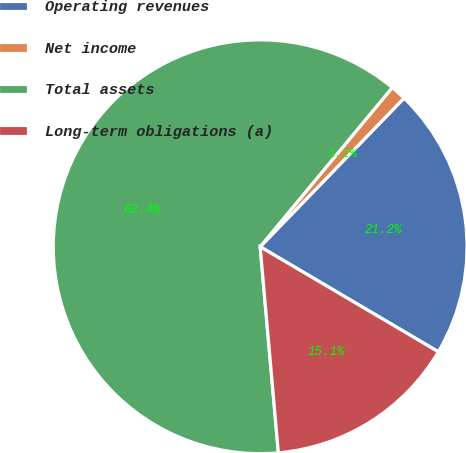Convert chart to OTSL. <chart><loc_0><loc_0><loc_500><loc_500><pie_chart><fcel>Operating revenues<fcel>Net income<fcel>Total assets<fcel>Long-term obligations (a)<nl><fcel>21.24%<fcel>1.22%<fcel>62.43%<fcel>15.12%<nl></chart> 